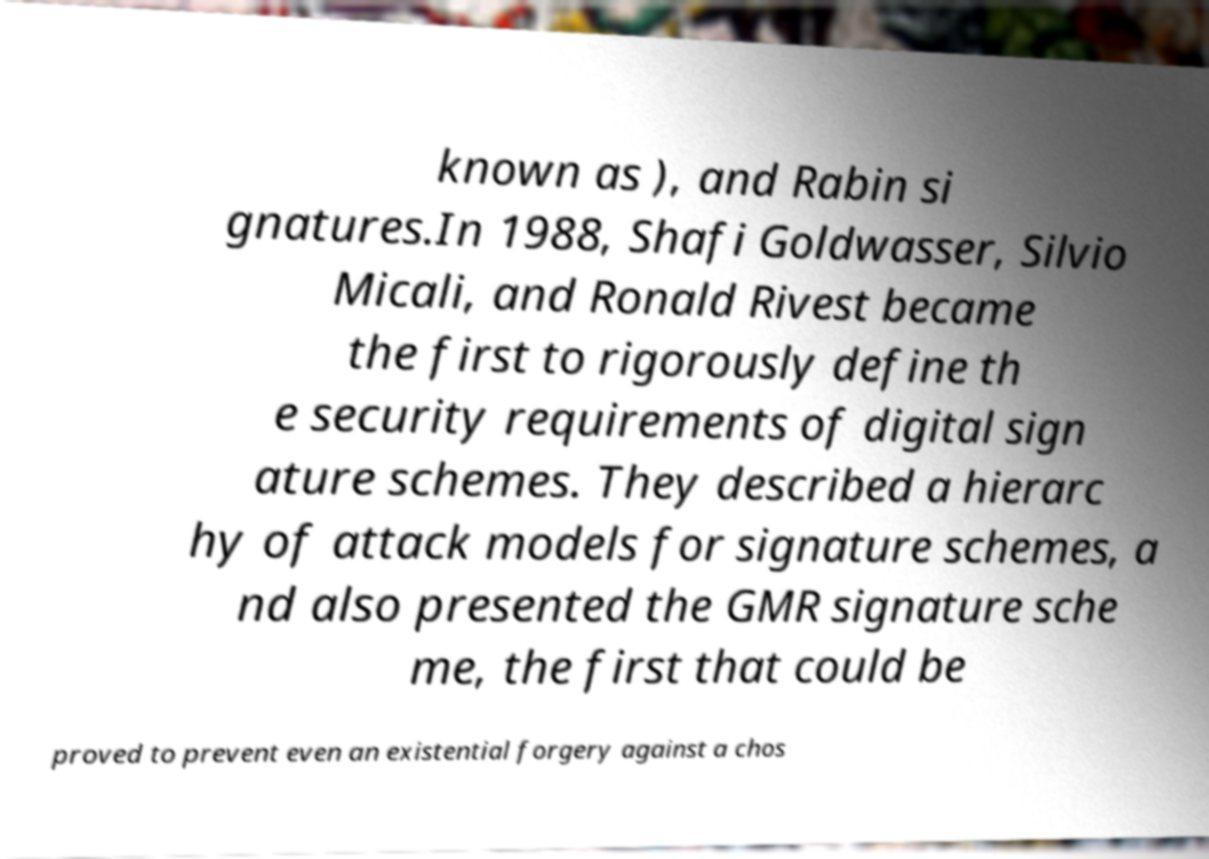What messages or text are displayed in this image? I need them in a readable, typed format. known as ), and Rabin si gnatures.In 1988, Shafi Goldwasser, Silvio Micali, and Ronald Rivest became the first to rigorously define th e security requirements of digital sign ature schemes. They described a hierarc hy of attack models for signature schemes, a nd also presented the GMR signature sche me, the first that could be proved to prevent even an existential forgery against a chos 